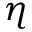<formula> <loc_0><loc_0><loc_500><loc_500>\eta</formula> 